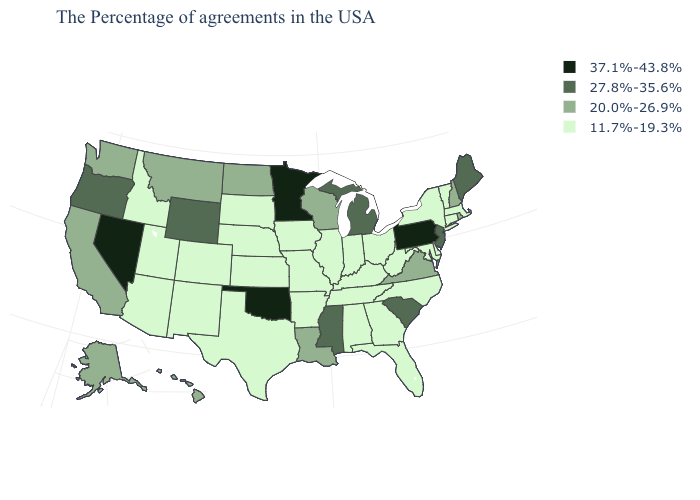Among the states that border Washington , which have the lowest value?
Keep it brief. Idaho. Among the states that border Maryland , which have the lowest value?
Keep it brief. Delaware, West Virginia. How many symbols are there in the legend?
Concise answer only. 4. What is the highest value in the MidWest ?
Be succinct. 37.1%-43.8%. What is the value of Minnesota?
Keep it brief. 37.1%-43.8%. What is the lowest value in the South?
Be succinct. 11.7%-19.3%. What is the lowest value in the MidWest?
Concise answer only. 11.7%-19.3%. What is the highest value in the Northeast ?
Answer briefly. 37.1%-43.8%. Does the first symbol in the legend represent the smallest category?
Write a very short answer. No. Which states have the highest value in the USA?
Short answer required. Pennsylvania, Minnesota, Oklahoma, Nevada. Does Wyoming have the highest value in the West?
Answer briefly. No. What is the value of Washington?
Short answer required. 20.0%-26.9%. Name the states that have a value in the range 27.8%-35.6%?
Be succinct. Maine, New Jersey, South Carolina, Michigan, Mississippi, Wyoming, Oregon. Does South Dakota have a lower value than Missouri?
Be succinct. No. 